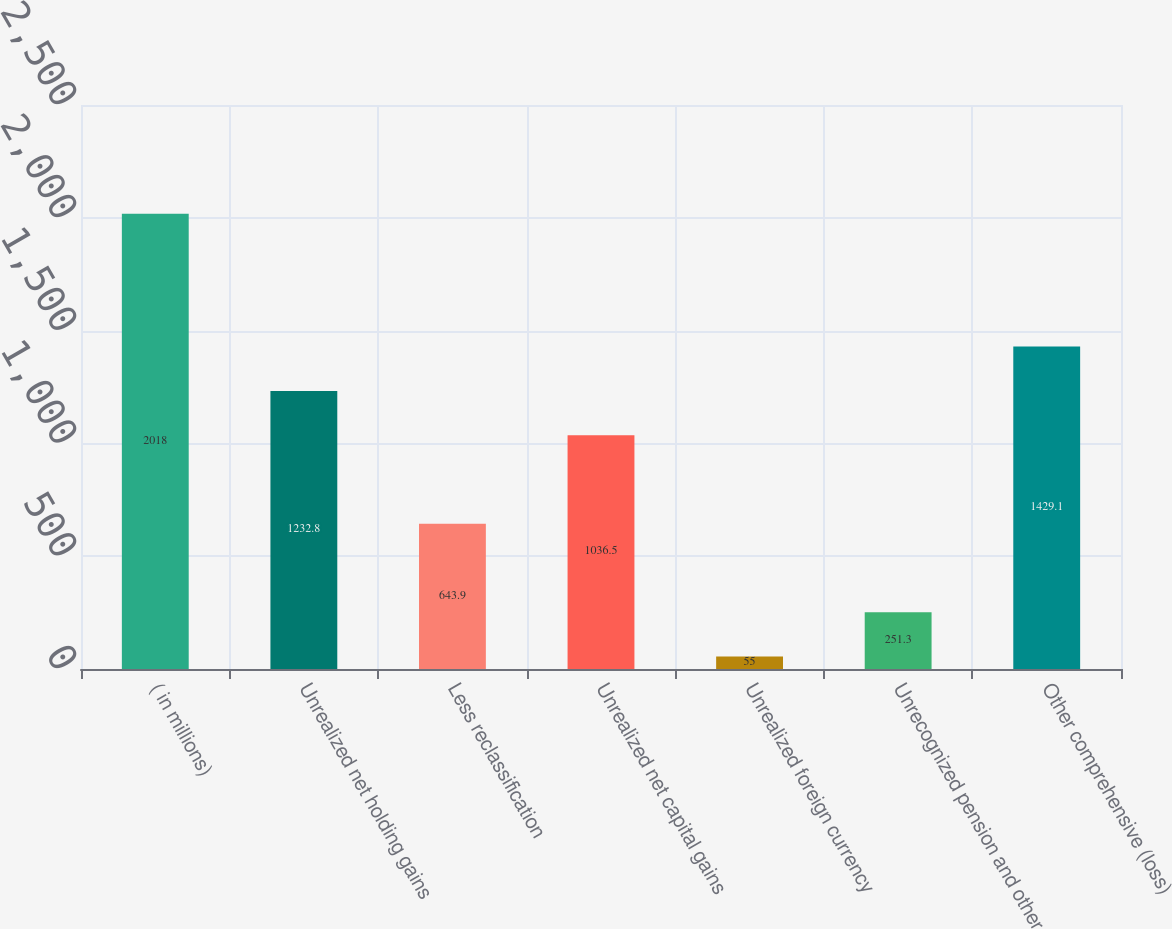<chart> <loc_0><loc_0><loc_500><loc_500><bar_chart><fcel>( in millions)<fcel>Unrealized net holding gains<fcel>Less reclassification<fcel>Unrealized net capital gains<fcel>Unrealized foreign currency<fcel>Unrecognized pension and other<fcel>Other comprehensive (loss)<nl><fcel>2018<fcel>1232.8<fcel>643.9<fcel>1036.5<fcel>55<fcel>251.3<fcel>1429.1<nl></chart> 